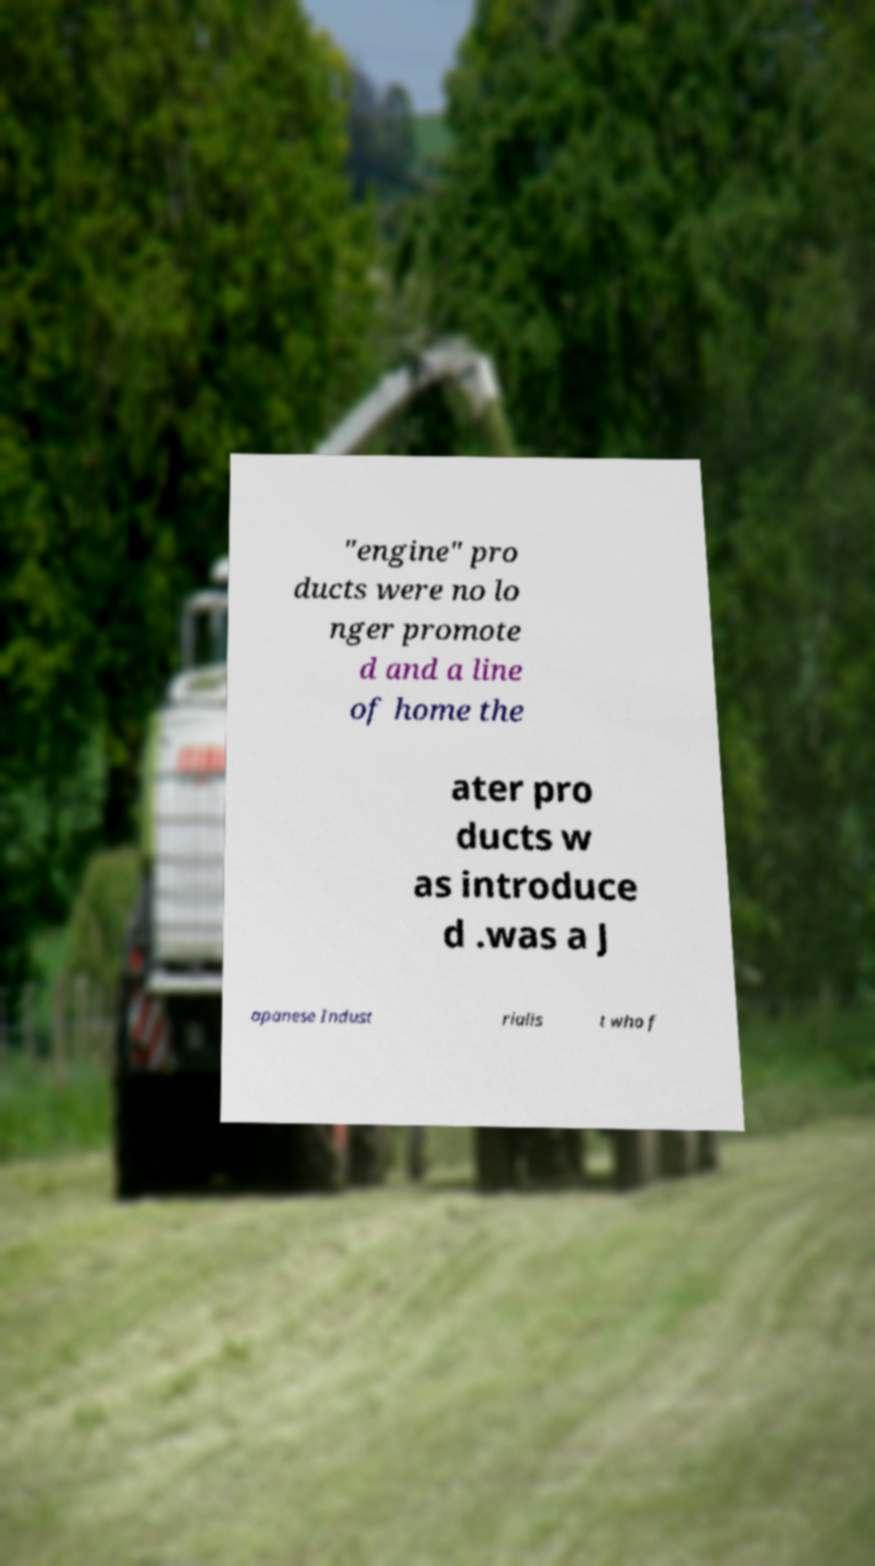I need the written content from this picture converted into text. Can you do that? "engine" pro ducts were no lo nger promote d and a line of home the ater pro ducts w as introduce d .was a J apanese Indust rialis t who f 